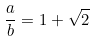<formula> <loc_0><loc_0><loc_500><loc_500>\frac { a } { b } = 1 + \sqrt { 2 }</formula> 